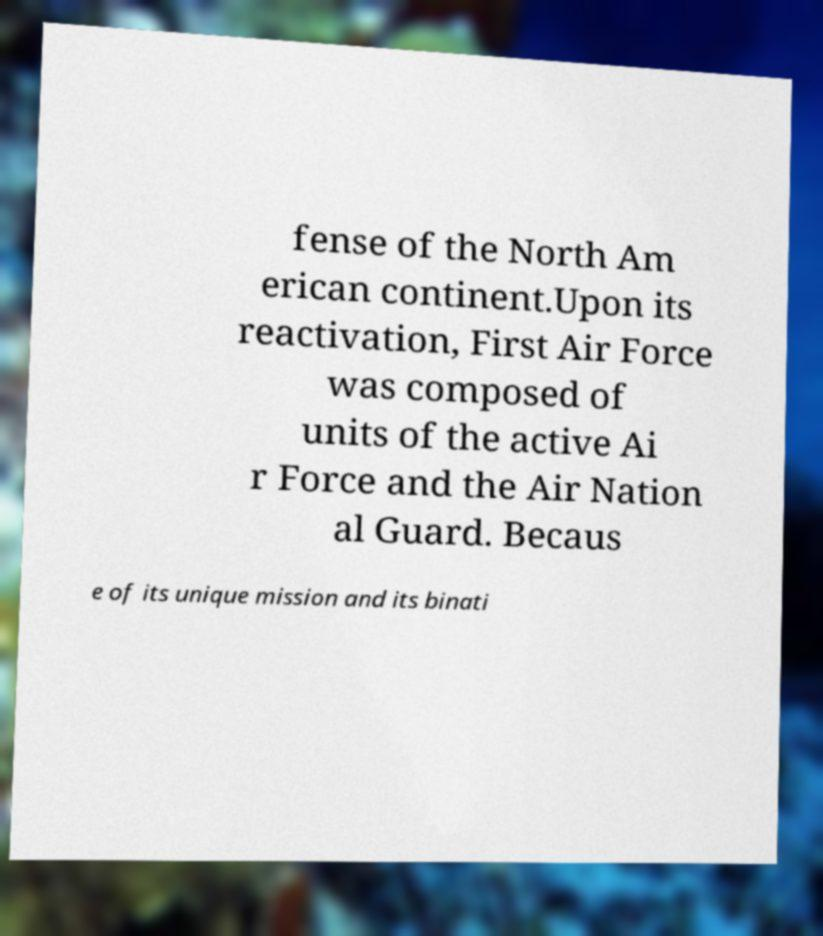Please identify and transcribe the text found in this image. fense of the North Am erican continent.Upon its reactivation, First Air Force was composed of units of the active Ai r Force and the Air Nation al Guard. Becaus e of its unique mission and its binati 